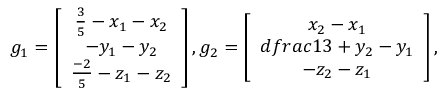<formula> <loc_0><loc_0><loc_500><loc_500>g _ { 1 } = \left [ \begin{array} { c c c } { \frac { 3 } { 5 } - x _ { 1 } - x _ { 2 } } \\ { - y _ { 1 } - y _ { 2 } } \\ { \frac { - 2 } { 5 } - z _ { 1 } - z _ { 2 } } \end{array} \right ] , g _ { 2 } = \left [ \begin{array} { c c c } { x _ { 2 } - x _ { 1 } } \\ { d f r a c { 1 } { 3 } + y _ { 2 } - y _ { 1 } } \\ { - z _ { 2 } - z _ { 1 } } \end{array} \right ] ,</formula> 